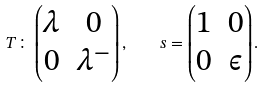Convert formula to latex. <formula><loc_0><loc_0><loc_500><loc_500>\, T \colon \begin{pmatrix} \lambda & 0 \\ 0 & \lambda ^ { - } \end{pmatrix} , \quad s = \begin{pmatrix} 1 & 0 \\ 0 & \epsilon \end{pmatrix} .</formula> 